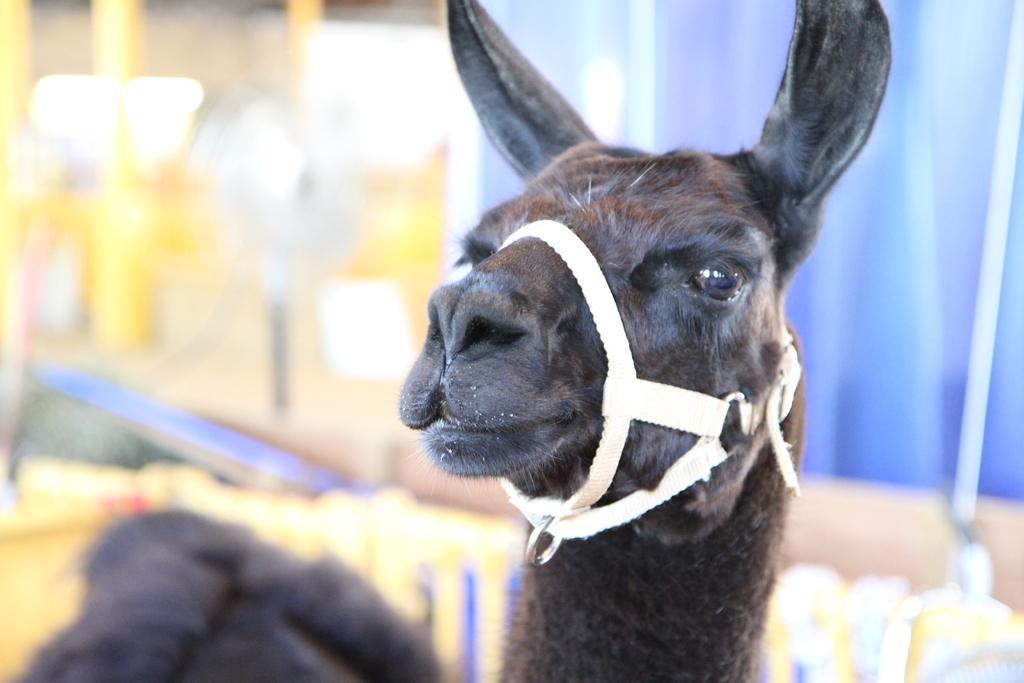In one or two sentences, can you explain what this image depicts? In this image we can see an animal and the background is blurred. 